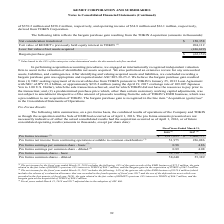Comparing values in Kemet Corporation's report, How many percent of the gain on sale of the EMD business was excluded from the net income in 2018? According to the financial document, 34 (percentage). The relevant text states: "2 million, respectively, and operating income of $34.8 million and $36.1 million, respectively, derived from TOKIN Corporation. 2 million, respectively, and operating income of $34.8 million and $36.1..." Also, What was the pro forma revenue in 2017? According to the financial document, 1,060,777 (in thousands). The relevant text states: "Pro forma revenues (3) $ 1,217,655 $ 1,060,777..." Also, What was the Pro forma common shares - diluted in 2018? According to the financial document, 58,640 (in thousands). The relevant text states: "Pro forma common shares - diluted 58,640 55,389..." Also, can you calculate: What was the change in Pro forma revenues between 2017 and 2018? Based on the calculation: 1,217,655-1,060,777, the result is 156878. This is based on the information: "Pro forma revenues (3) $ 1,217,655 $ 1,060,777 Pro forma revenues (3) $ 1,217,655 $ 1,060,777..." The key data points involved are: 1,060,777, 1,217,655. Additionally, Which years did the basic Pro forma earnings per common share exceed $1.00? According to the financial document, 2017. The relevant text states: "2018 (1) 2017 (2)..." Also, can you calculate: What was the percentage change in the diluted Pro forma common shares between 2017 and 2018? To answer this question, I need to perform calculations using the financial data. The calculation is: (58,640-55,389)/55,389, which equals 5.87 (percentage). This is based on the information: "Pro forma common shares - diluted 58,640 55,389 Pro forma common shares - diluted 58,640 55,389..." The key data points involved are: 55,389, 58,640. 